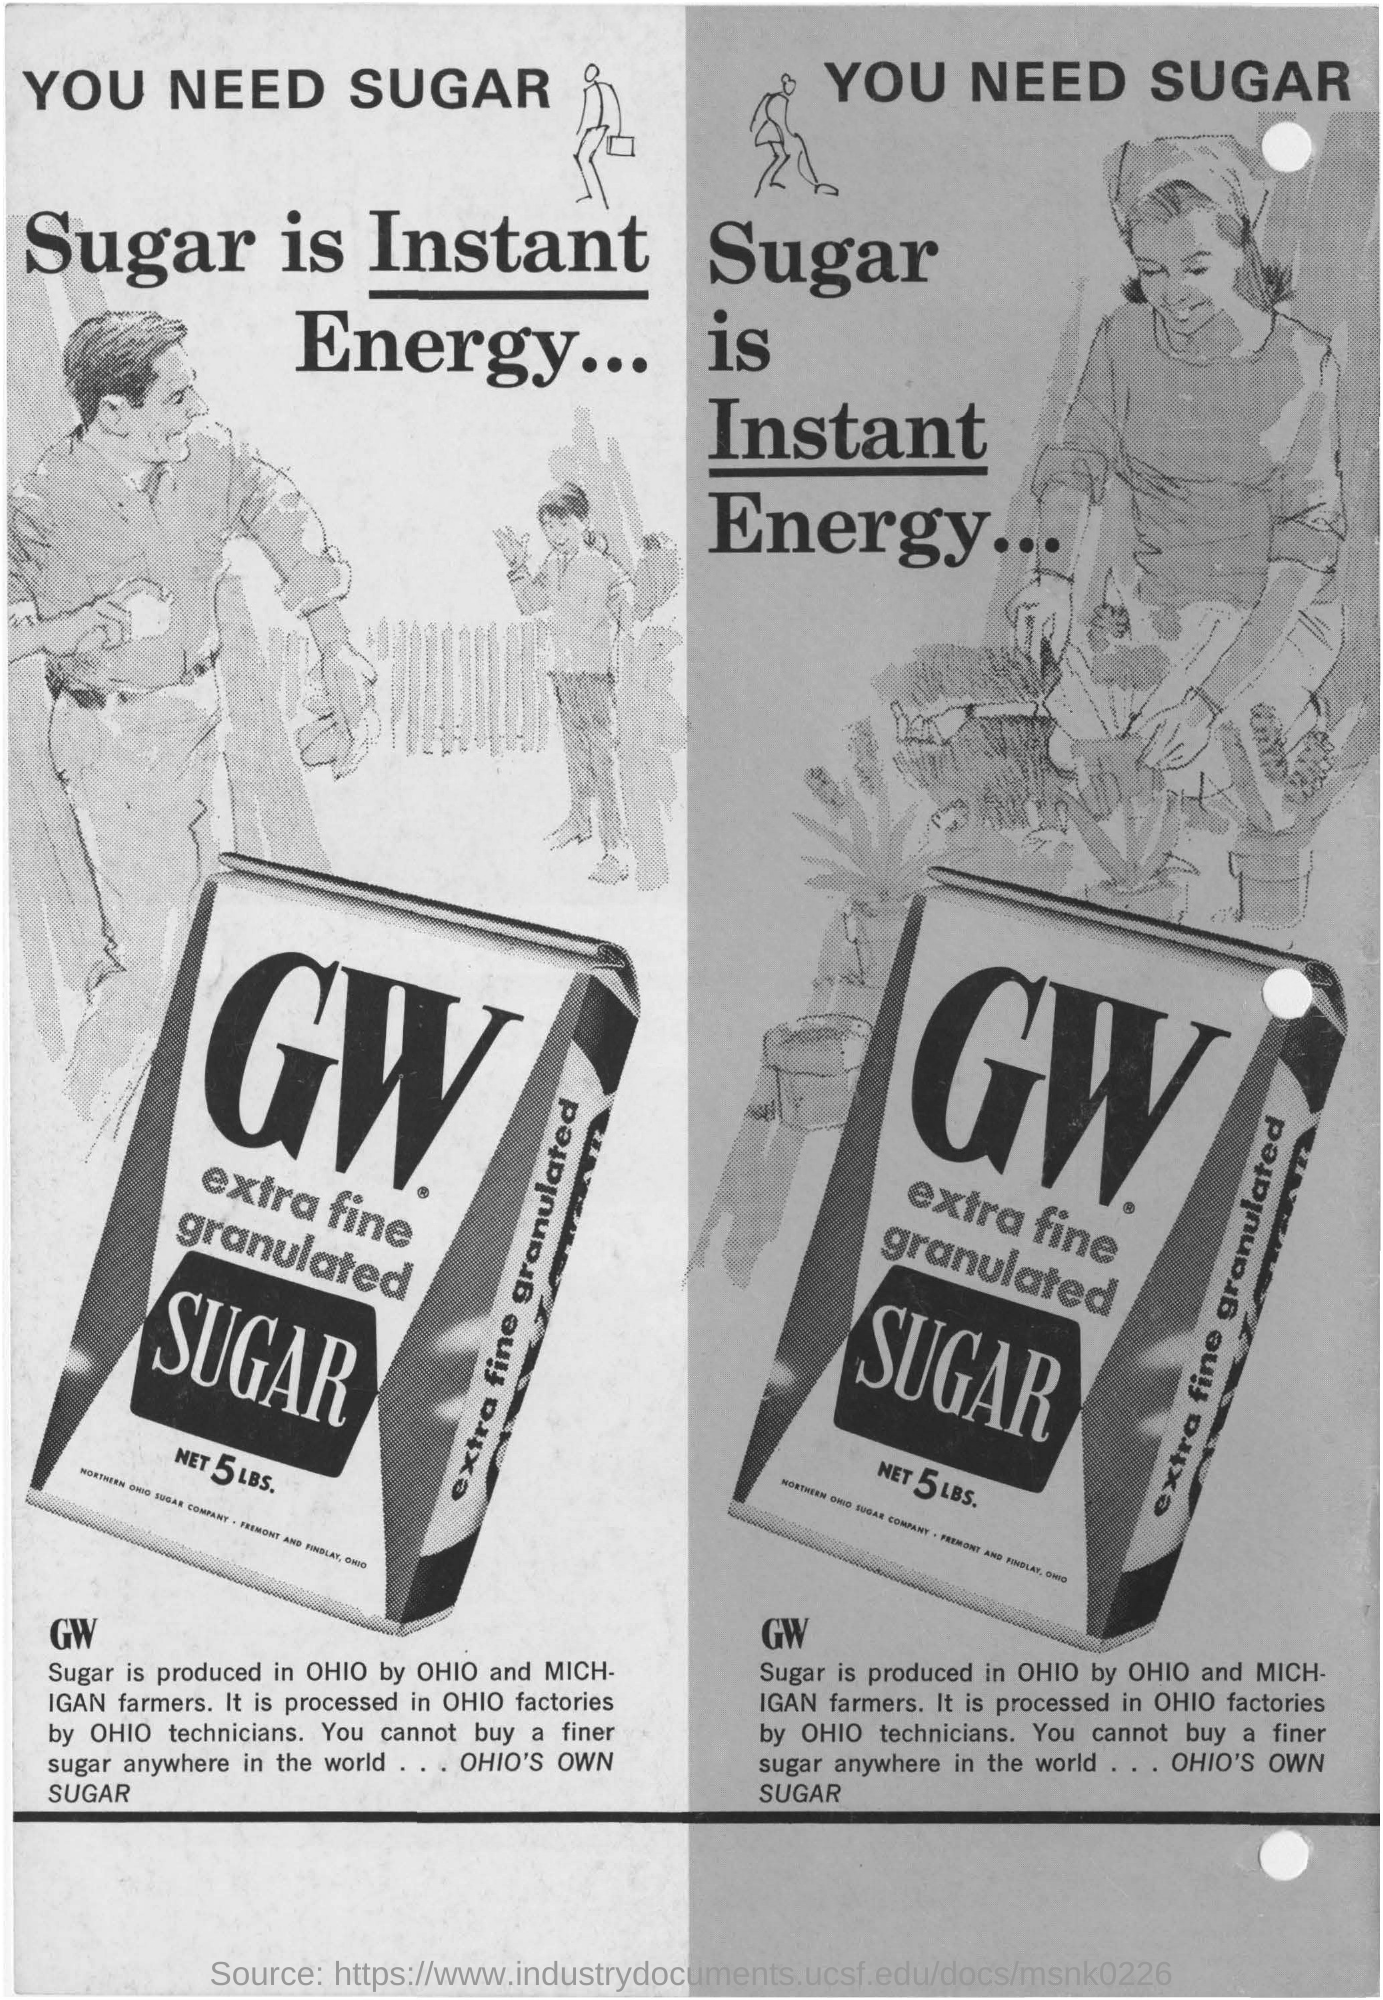Point out several critical features in this image. The GW Sugar is being processed in factories located in Ohio. GW Sugar is produced in the state of Ohio. GW Sugar is produced by Ohio and Michigan farmers. 